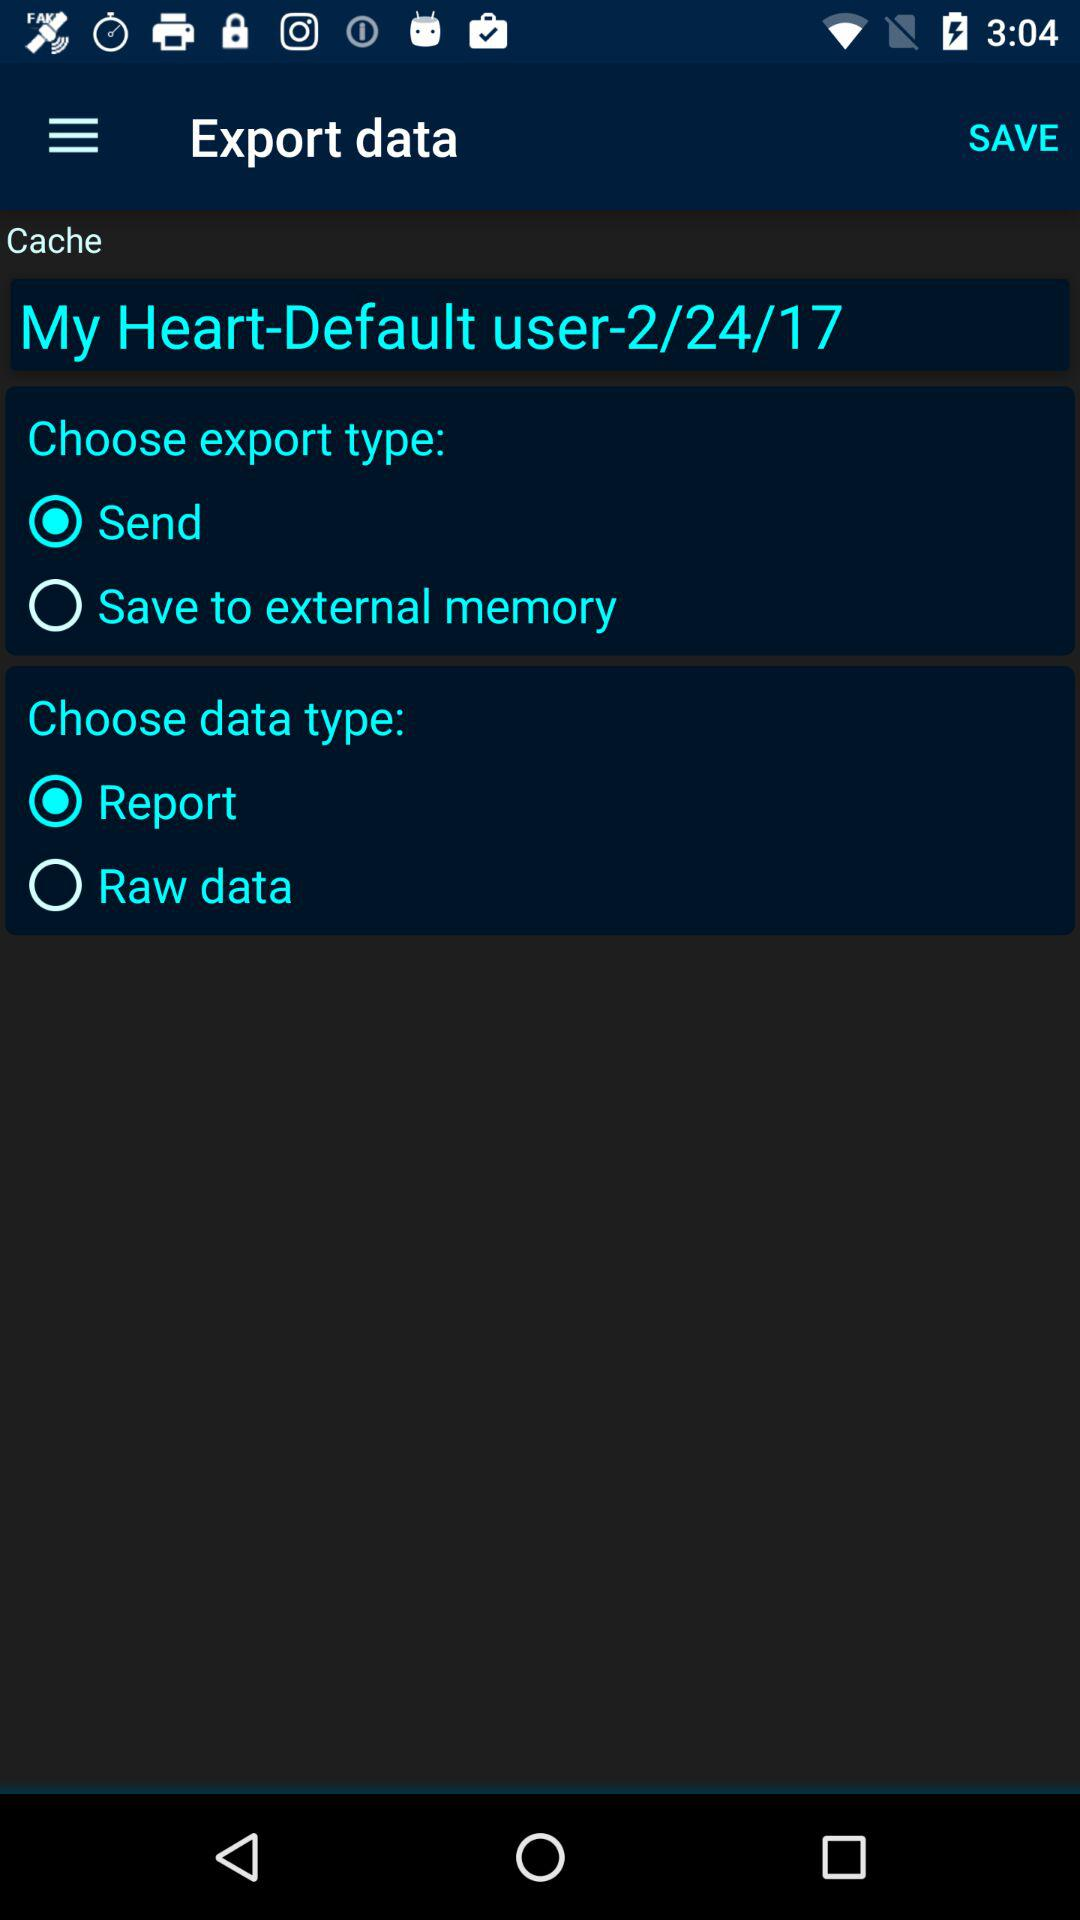Which data type has been selected? The selected data type is "Report". 